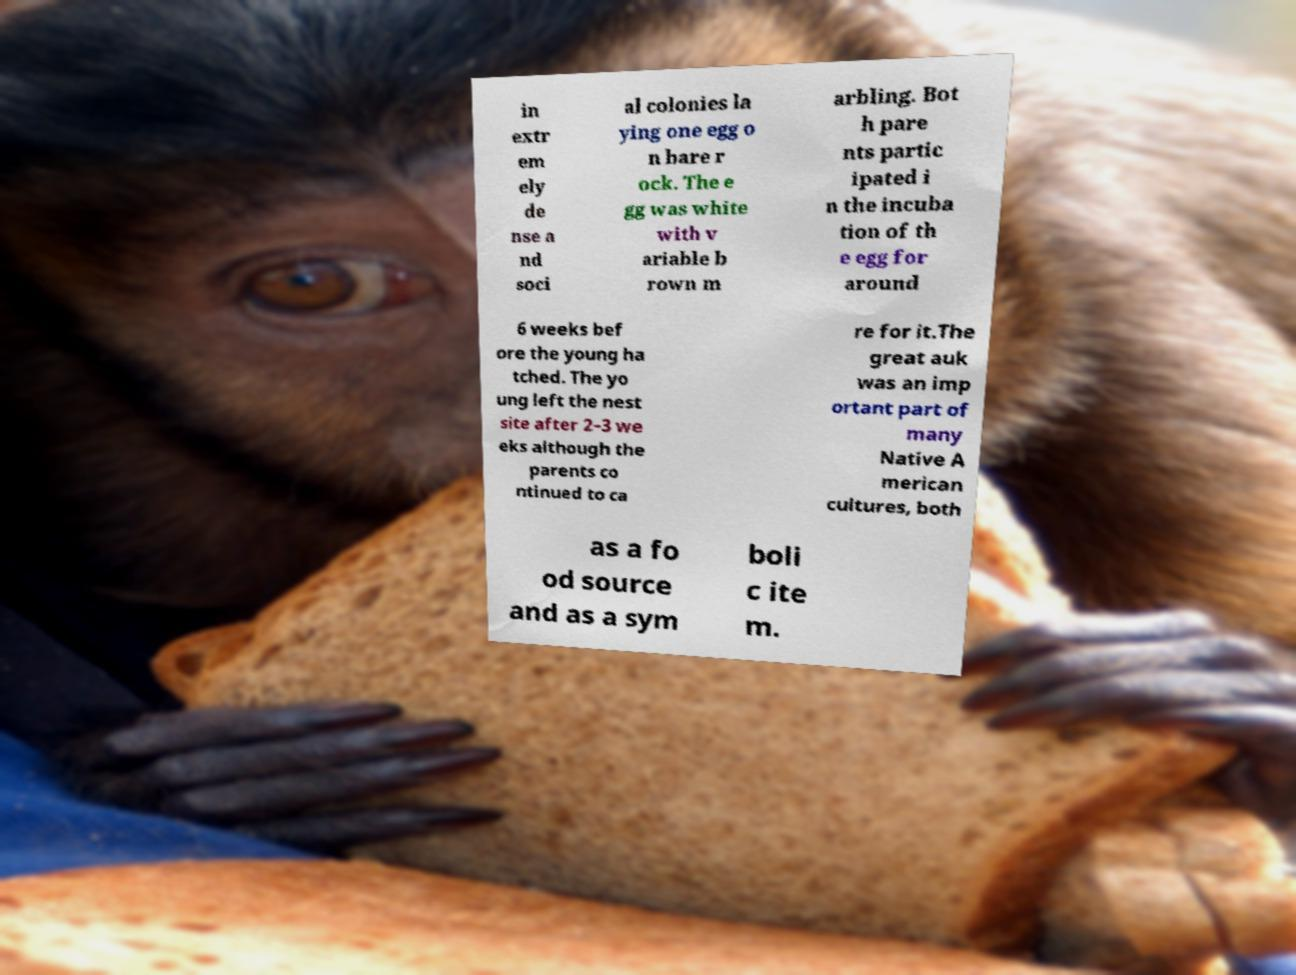Can you read and provide the text displayed in the image?This photo seems to have some interesting text. Can you extract and type it out for me? in extr em ely de nse a nd soci al colonies la ying one egg o n bare r ock. The e gg was white with v ariable b rown m arbling. Bot h pare nts partic ipated i n the incuba tion of th e egg for around 6 weeks bef ore the young ha tched. The yo ung left the nest site after 2–3 we eks although the parents co ntinued to ca re for it.The great auk was an imp ortant part of many Native A merican cultures, both as a fo od source and as a sym boli c ite m. 